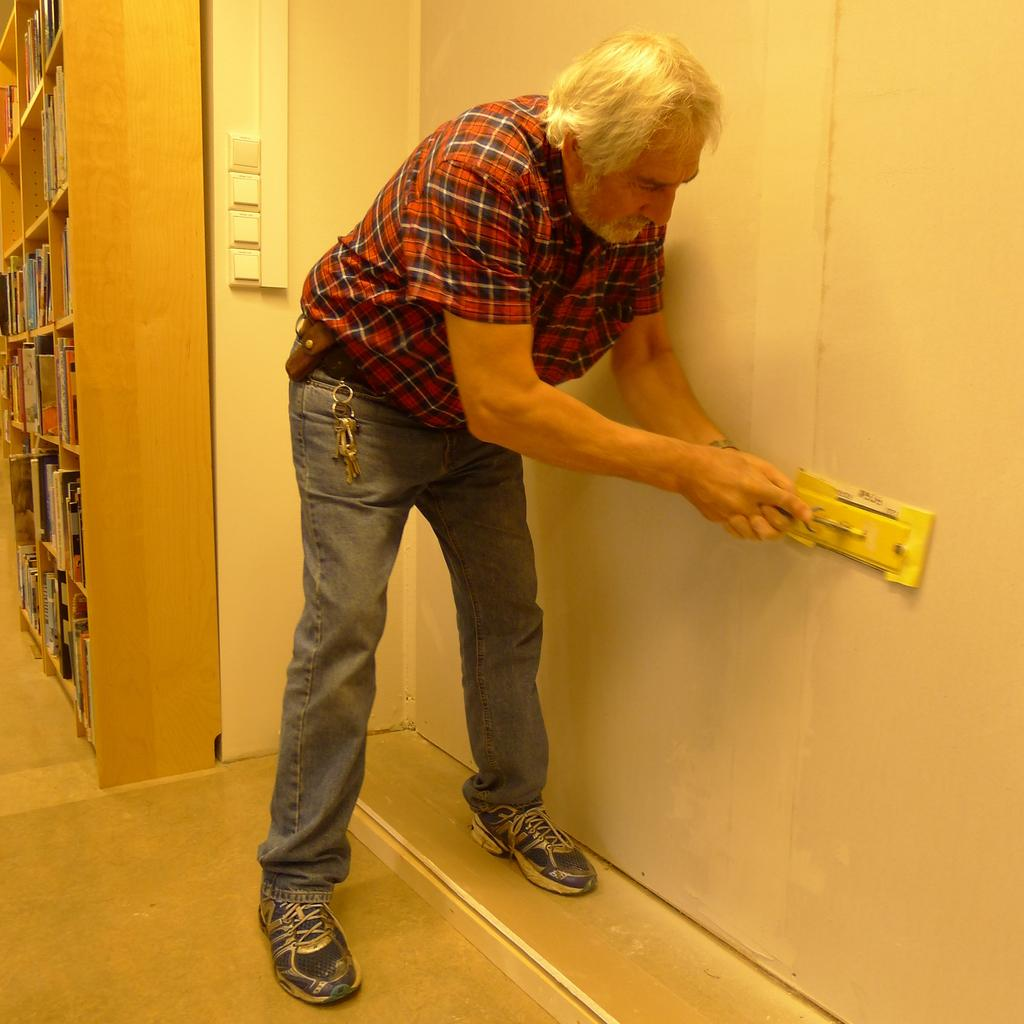What is the person in the image holding? The person is holding an object in the image. What can be seen on the wall in the image? There are objects on the wall in the image. How many books are visible on the rack in the image? There are many books on a rack in the image. What type of item is visible that is often used for unlocking doors? Keys are visible in the image. What color is the egg that the coach is holding in the image? There is no egg or coach present in the image. 